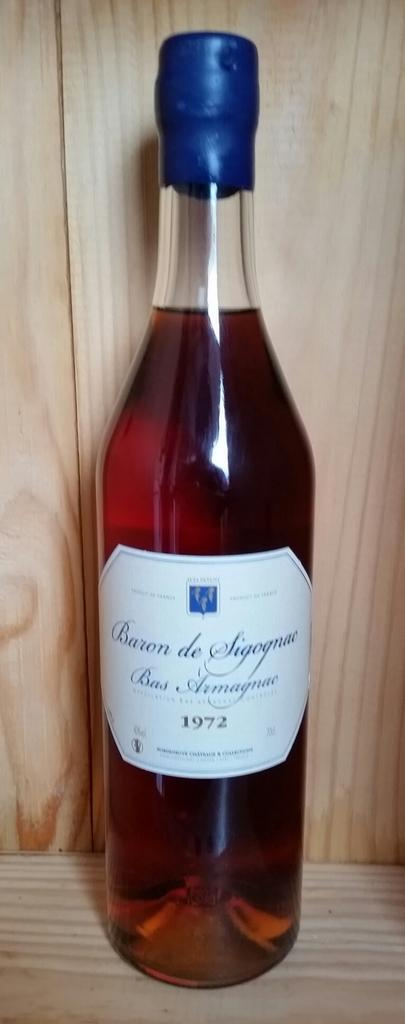<image>
Write a terse but informative summary of the picture. A bottle of Baron de Sigognac placed on a wooden surface. 